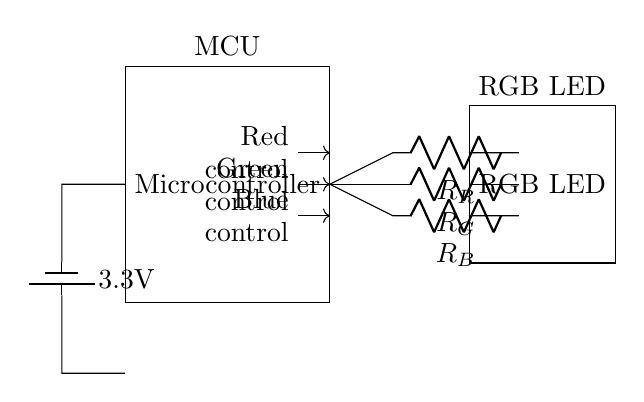What is the power supply voltage for this circuit? The circuit shows a label on the left specifying 3.3V, which indicates the power supply voltage provided to the circuit.
Answer: 3.3V What type of LED is used in this circuit? The circuit diagram specifically labels the LED as an RGB LED, indicating that it can display red, green, and blue colors.
Answer: RGB LED How many control pins are there for the LED? The circuit shows three arrows leading from the microcontroller to the LED, each indicating a control pin for red, green, and blue.
Answer: Three What do the resistors in the circuit control? The resistors are denoted as R_R, R_G, and R_B next to their respective control pins, suggesting they limit the current flowing to the LED colors red, green, and blue, respectively.
Answer: Current limiting Which component is responsible for color control in the circuit? The microcontroller is the component that connects to the control pins marked for red, green, and blue, indicating that it controls the colors emitted by the RGB LED.
Answer: Microcontroller Where is the power supply connected in the circuit? The power supply is connected to the left side of the microcontroller, indicated by the connection line moving towards the battery symbol, then downward to the ground.
Answer: Left side of the microcontroller 